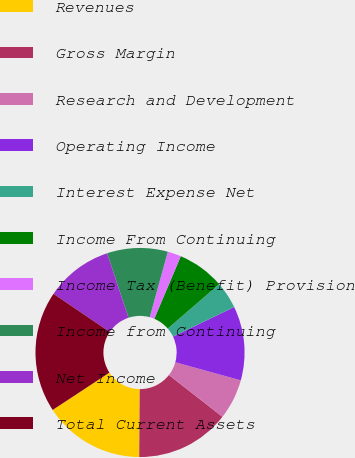Convert chart. <chart><loc_0><loc_0><loc_500><loc_500><pie_chart><fcel>Revenues<fcel>Gross Margin<fcel>Research and Development<fcel>Operating Income<fcel>Interest Expense Net<fcel>Income From Continuing<fcel>Income Tax (Benefit) Provision<fcel>Income from Continuing<fcel>Net Income<fcel>Total Current Assets<nl><fcel>15.62%<fcel>14.58%<fcel>6.25%<fcel>11.46%<fcel>4.17%<fcel>7.29%<fcel>2.09%<fcel>9.38%<fcel>10.42%<fcel>18.74%<nl></chart> 